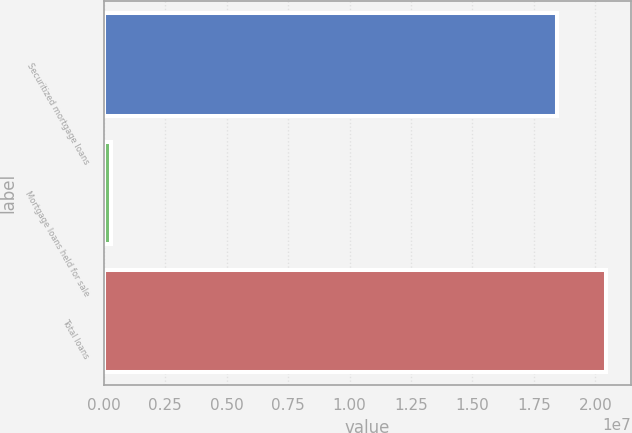Convert chart to OTSL. <chart><loc_0><loc_0><loc_500><loc_500><bar_chart><fcel>Securitized mortgage loans<fcel>Mortgage loans held for sale<fcel>Total loans<nl><fcel>1.84349e+07<fcel>295208<fcel>2.0424e+07<nl></chart> 